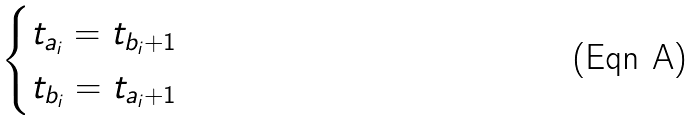<formula> <loc_0><loc_0><loc_500><loc_500>\begin{cases} t _ { a _ { i } } = t _ { b _ { i } + 1 } \\ t _ { b _ { i } } = t _ { a _ { i } + 1 } \end{cases}</formula> 